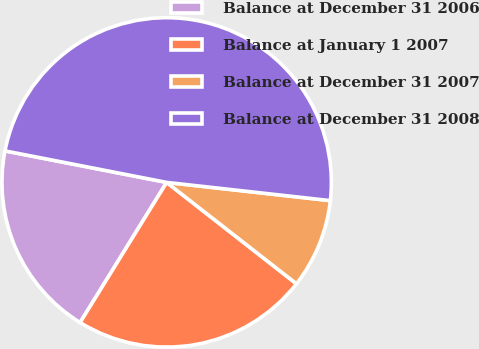<chart> <loc_0><loc_0><loc_500><loc_500><pie_chart><fcel>Balance at December 31 2006<fcel>Balance at January 1 2007<fcel>Balance at December 31 2007<fcel>Balance at December 31 2008<nl><fcel>19.26%<fcel>23.25%<fcel>8.79%<fcel>48.7%<nl></chart> 